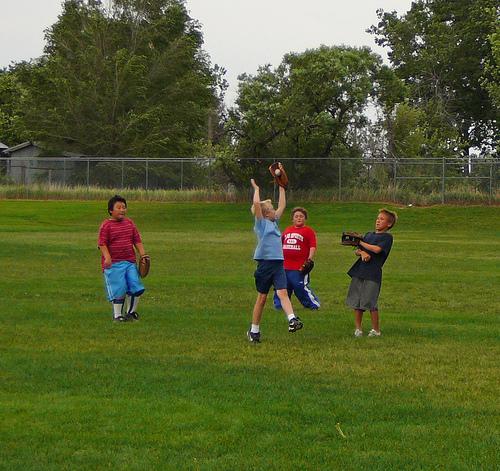What is everyone trying to catch?
Short answer required. Baseball. Is the child in the center left or right handed?
Be succinct. Right. What is the man throwing?
Short answer required. Baseball. What are the children doing?
Short answer required. Playing baseball. What are the boys reaching for?
Be succinct. Baseball. What game is being played?
Write a very short answer. Baseball. Did the boy catch the ball?
Answer briefly. Yes. What is the man reaching for?
Write a very short answer. Baseball. What are they playing?
Answer briefly. Baseball. What sport is this?
Give a very brief answer. Baseball. Which of the boy's feet are in the air?
Short answer required. Left. What kind of ball are the men using?
Concise answer only. Baseball. Are they playing just for fun?
Give a very brief answer. Yes. 